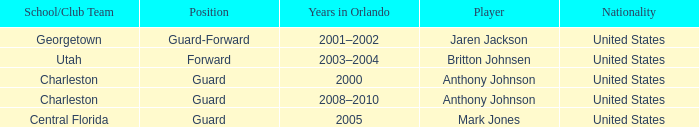Who was the Player that spent the Year 2005 in Orlando? Mark Jones. 